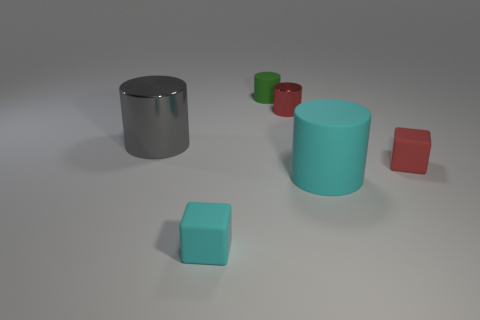Add 1 brown rubber blocks. How many objects exist? 7 Subtract all cylinders. How many objects are left? 2 Subtract all metallic cylinders. Subtract all green things. How many objects are left? 3 Add 4 tiny cyan matte blocks. How many tiny cyan matte blocks are left? 5 Add 5 small cylinders. How many small cylinders exist? 7 Subtract 0 cyan balls. How many objects are left? 6 